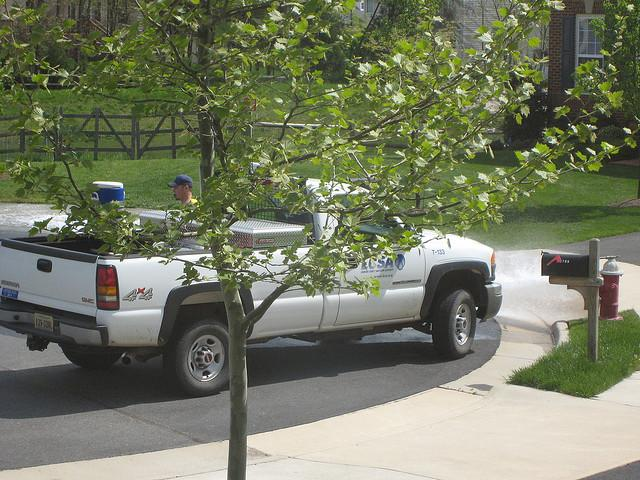What does he do? construction 